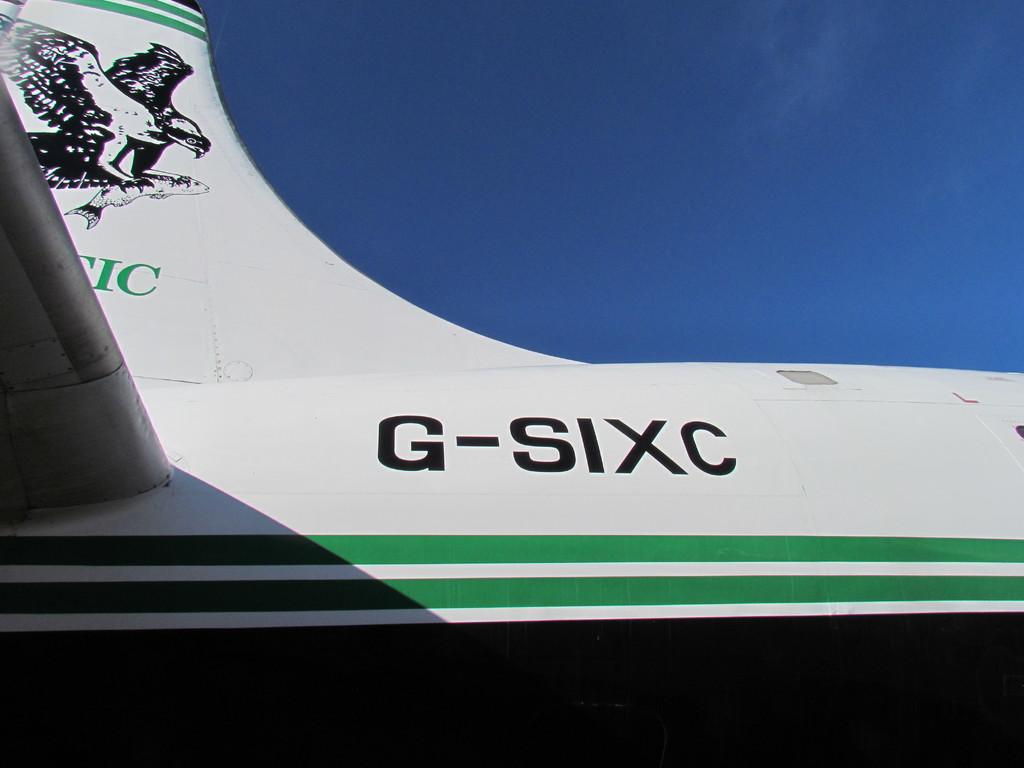What is the first letter of the black letters on the plane?
Give a very brief answer. G. 